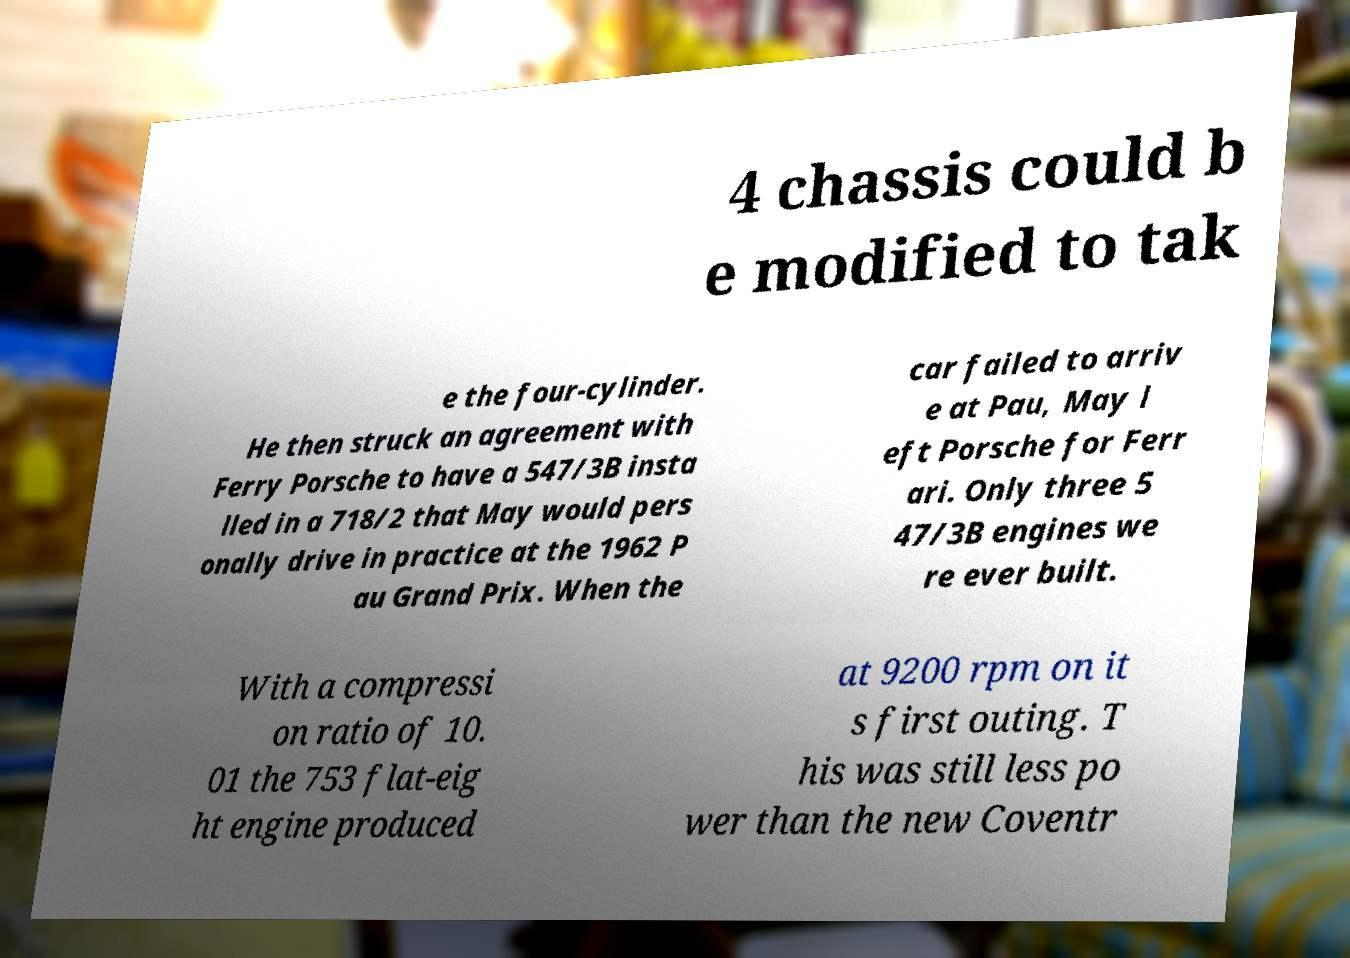Could you assist in decoding the text presented in this image and type it out clearly? 4 chassis could b e modified to tak e the four-cylinder. He then struck an agreement with Ferry Porsche to have a 547/3B insta lled in a 718/2 that May would pers onally drive in practice at the 1962 P au Grand Prix. When the car failed to arriv e at Pau, May l eft Porsche for Ferr ari. Only three 5 47/3B engines we re ever built. With a compressi on ratio of 10. 01 the 753 flat-eig ht engine produced at 9200 rpm on it s first outing. T his was still less po wer than the new Coventr 